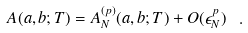Convert formula to latex. <formula><loc_0><loc_0><loc_500><loc_500>A ( a , b ; T ) = A ^ { ( p ) } _ { N } ( a , b ; T ) + O ( \epsilon _ { N } ^ { p } ) \ .</formula> 